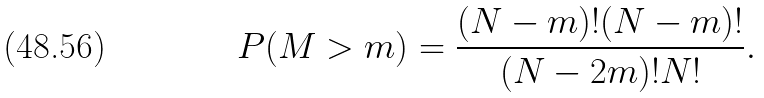Convert formula to latex. <formula><loc_0><loc_0><loc_500><loc_500>P ( M > m ) = \frac { ( N - m ) ! ( N - m ) ! } { ( N - 2 m ) ! N ! } .</formula> 